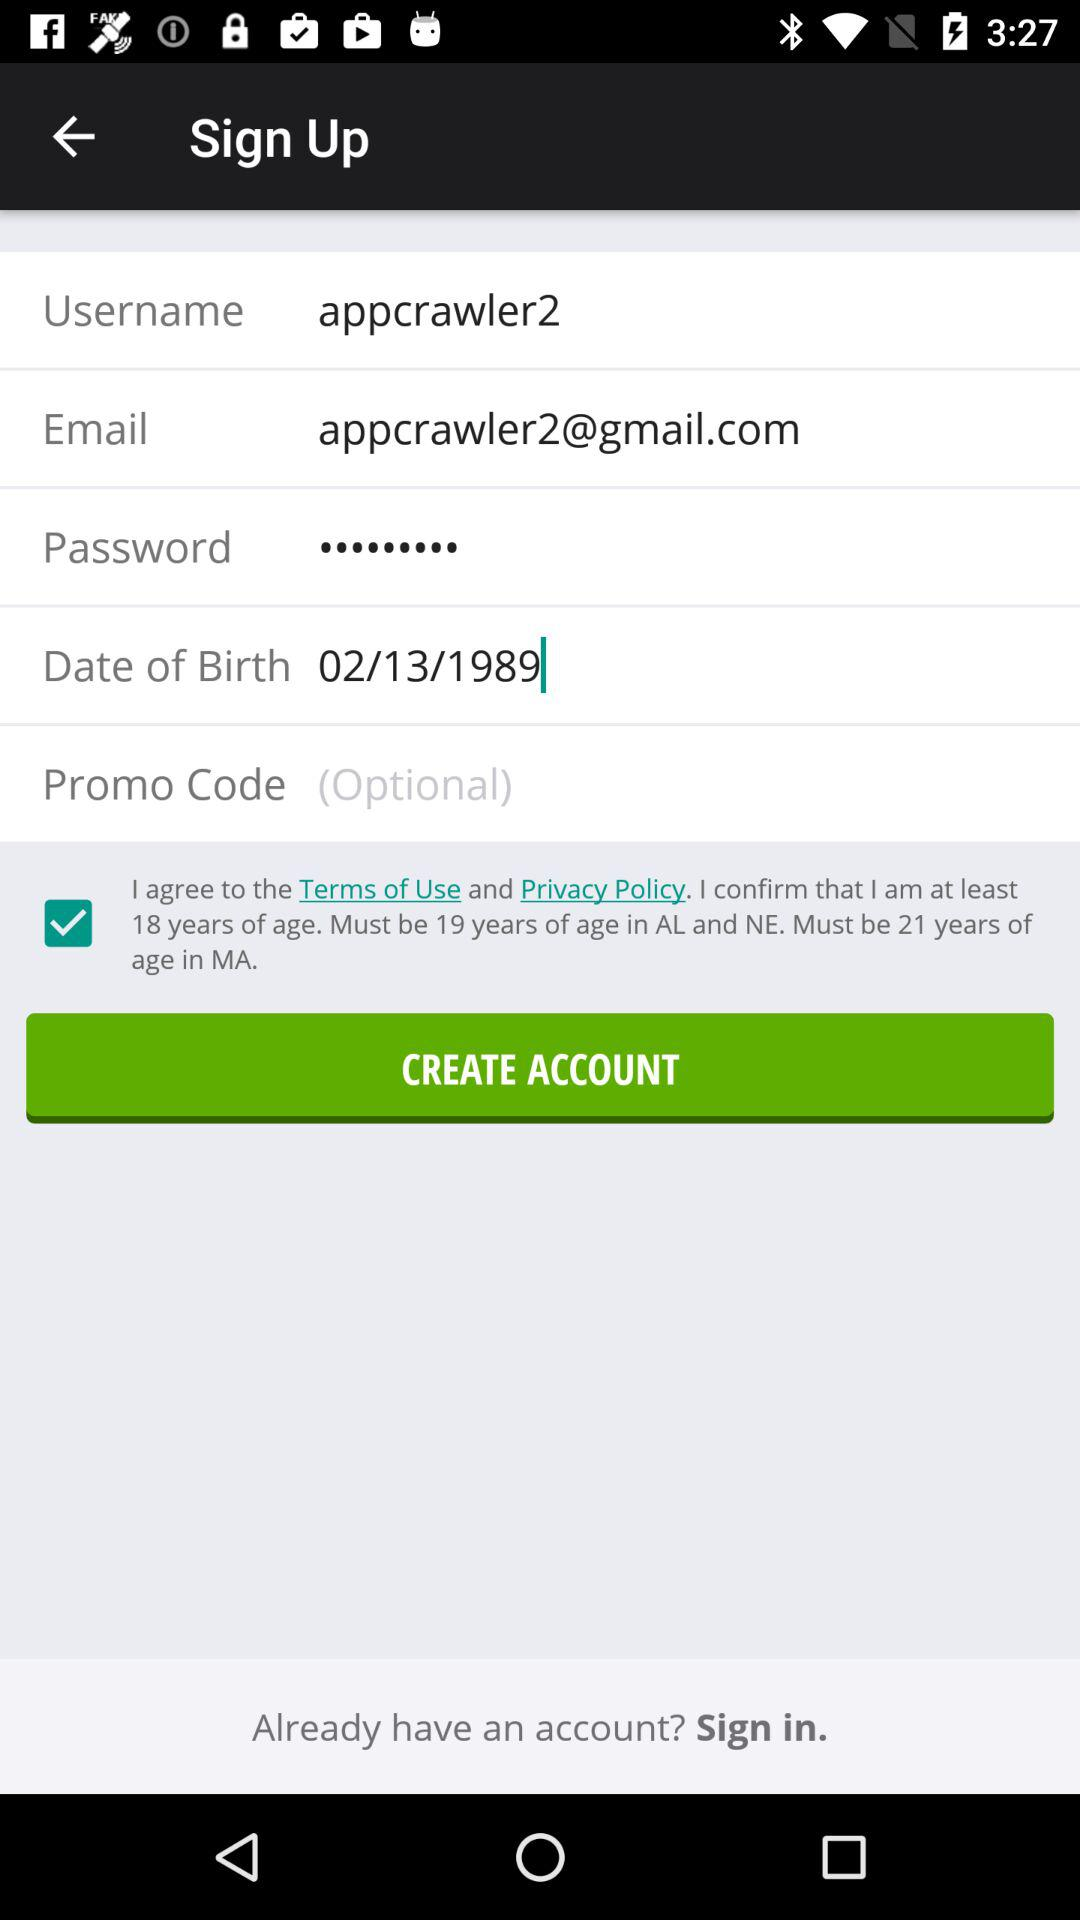What is the date of birth? The date of birth is 02/13/1989. 